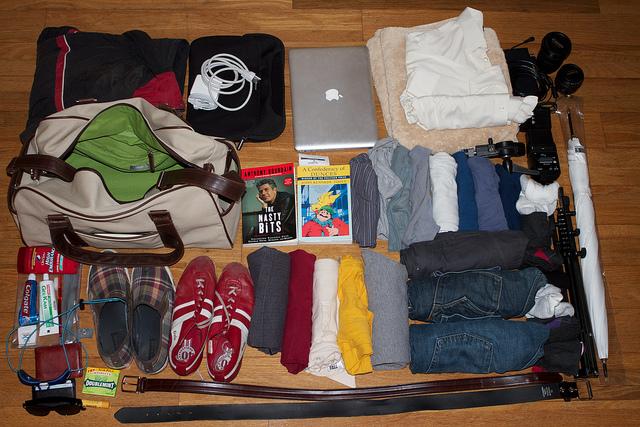Is this person packing for a trip?
Short answer required. Yes. What is next to the bag?
Be succinct. Book. Who is packing male or female?
Be succinct. Male. 